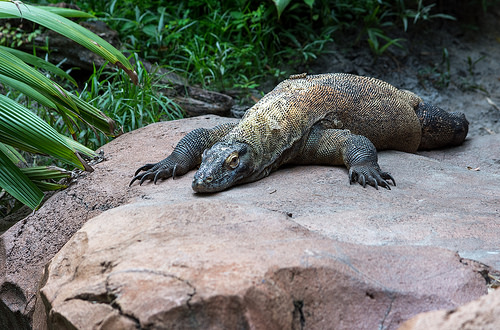<image>
Can you confirm if the lizard is in the rock? No. The lizard is not contained within the rock. These objects have a different spatial relationship. 